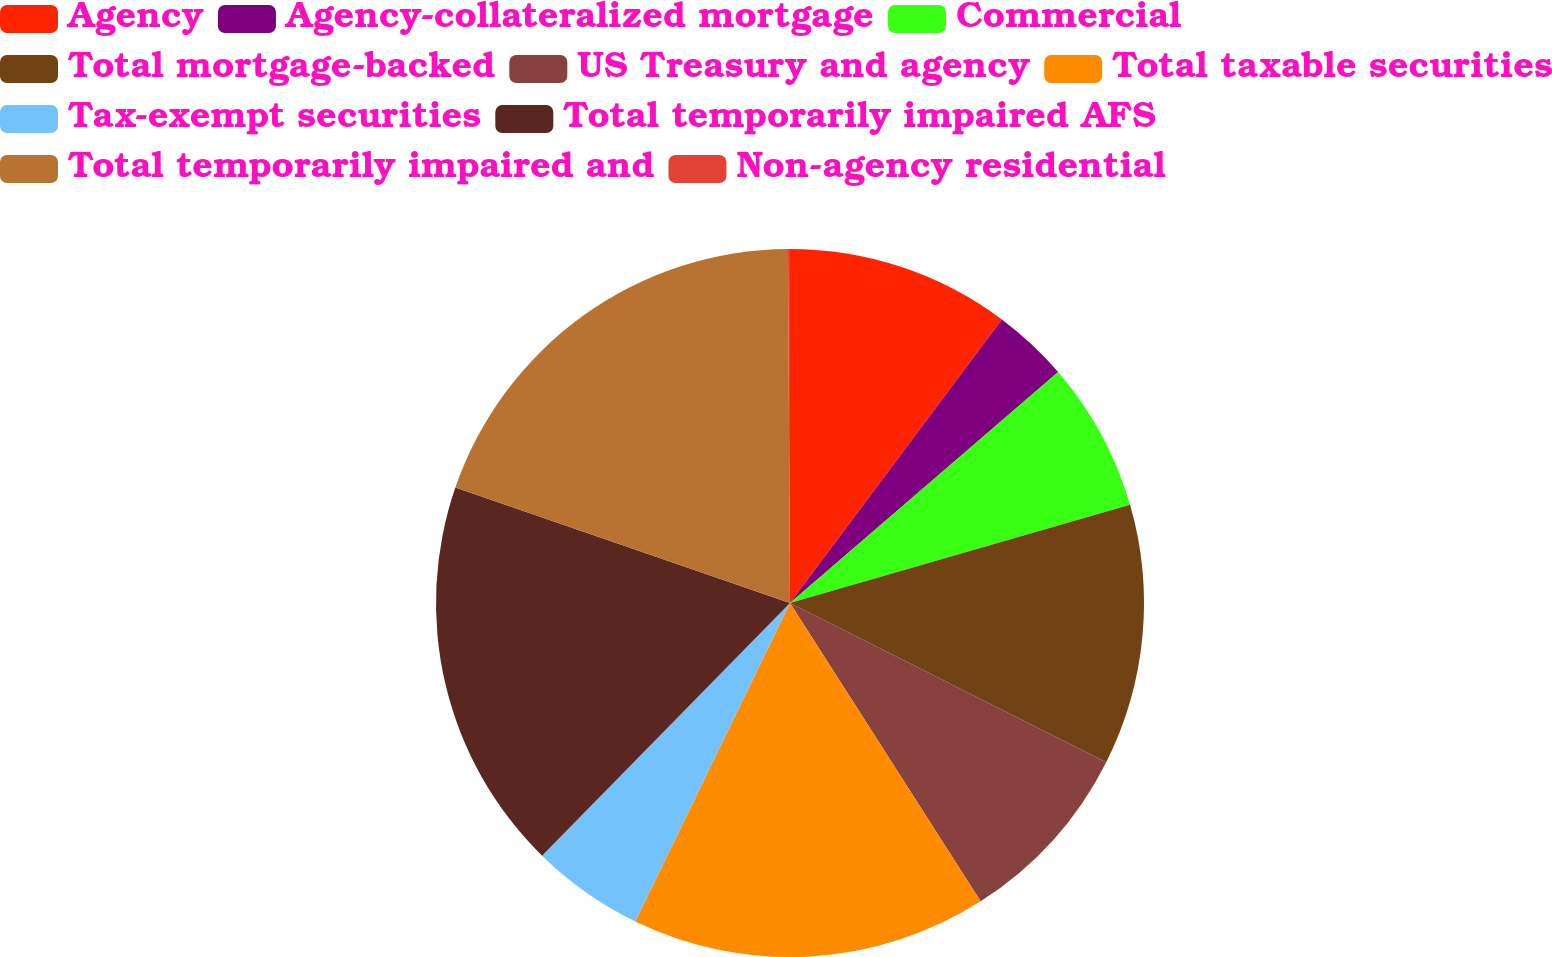Convert chart. <chart><loc_0><loc_0><loc_500><loc_500><pie_chart><fcel>Agency<fcel>Agency-collateralized mortgage<fcel>Commercial<fcel>Total mortgage-backed<fcel>US Treasury and agency<fcel>Total taxable securities<fcel>Tax-exempt securities<fcel>Total temporarily impaired AFS<fcel>Total temporarily impaired and<fcel>Non-agency residential<nl><fcel>10.21%<fcel>3.47%<fcel>6.84%<fcel>11.9%<fcel>8.53%<fcel>16.25%<fcel>5.15%<fcel>17.94%<fcel>19.62%<fcel>0.09%<nl></chart> 